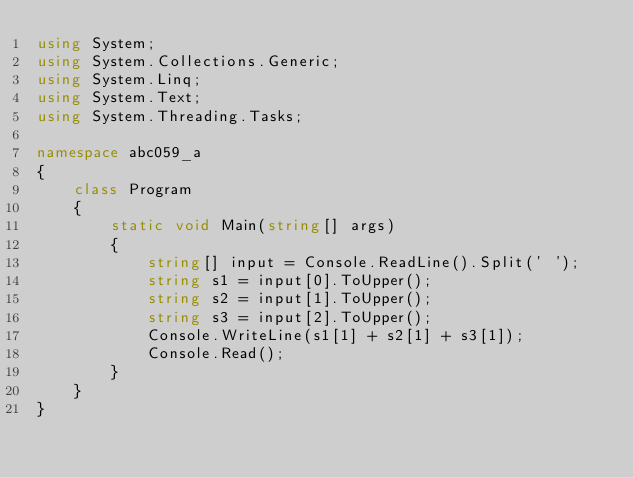<code> <loc_0><loc_0><loc_500><loc_500><_C#_>using System;
using System.Collections.Generic;
using System.Linq;
using System.Text;
using System.Threading.Tasks;

namespace abc059_a
{
    class Program
    {
        static void Main(string[] args)
        {
            string[] input = Console.ReadLine().Split(' ');
            string s1 = input[0].ToUpper();
            string s2 = input[1].ToUpper();
            string s3 = input[2].ToUpper();
            Console.WriteLine(s1[1] + s2[1] + s3[1]);
            Console.Read();
        }
    }
}
</code> 